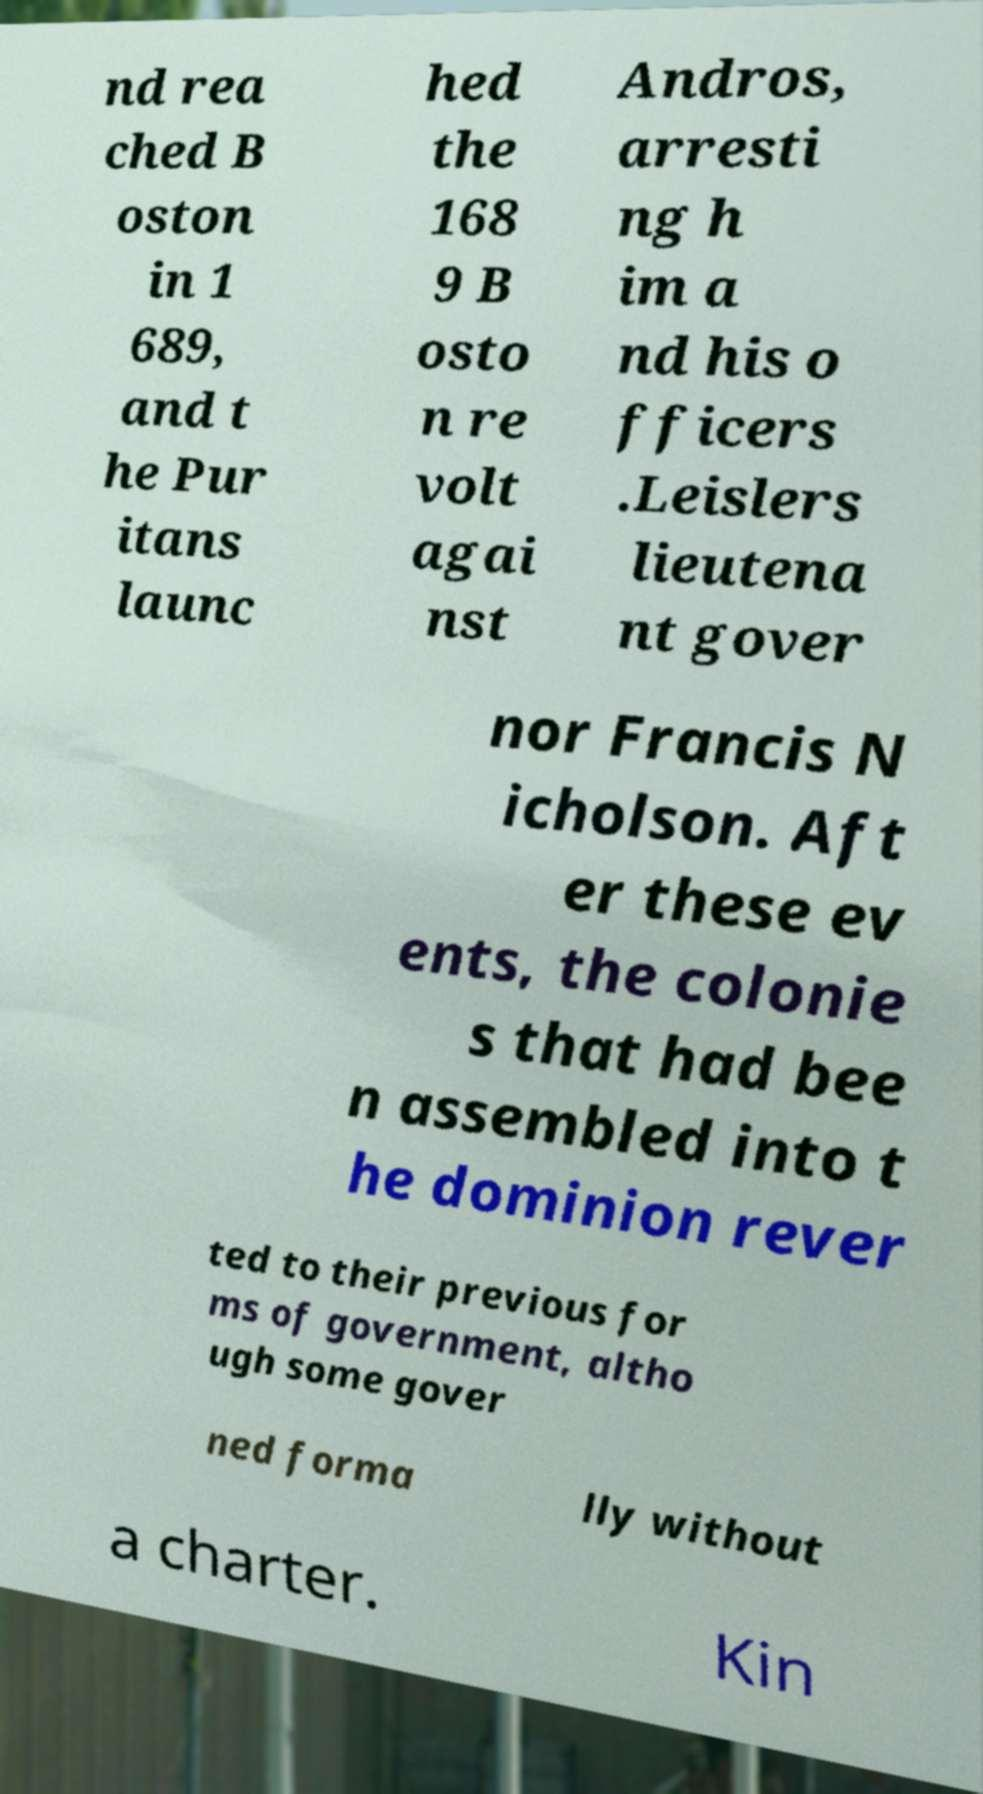Can you read and provide the text displayed in the image?This photo seems to have some interesting text. Can you extract and type it out for me? nd rea ched B oston in 1 689, and t he Pur itans launc hed the 168 9 B osto n re volt agai nst Andros, arresti ng h im a nd his o fficers .Leislers lieutena nt gover nor Francis N icholson. Aft er these ev ents, the colonie s that had bee n assembled into t he dominion rever ted to their previous for ms of government, altho ugh some gover ned forma lly without a charter. Kin 